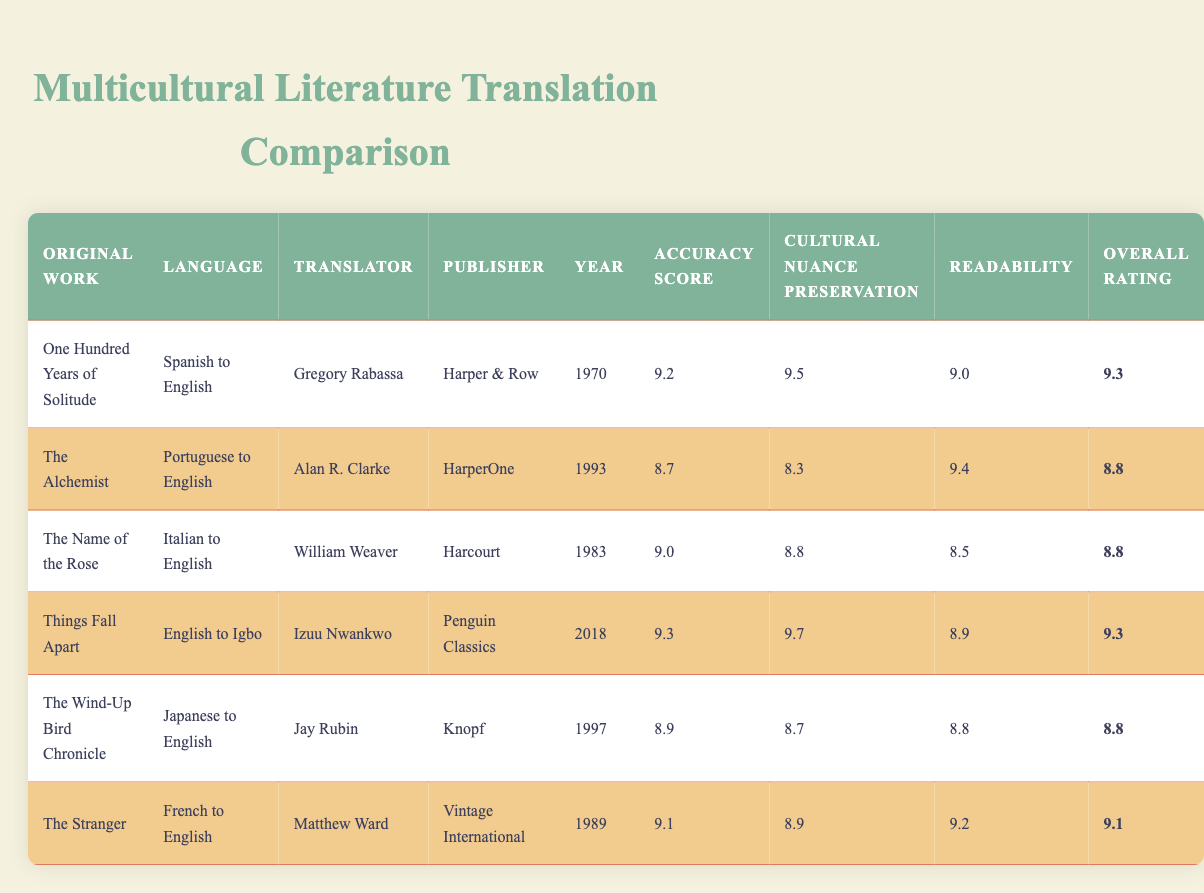What is the overall rating of "One Hundred Years of Solitude"? The overall rating for "One Hundred Years of Solitude" is displayed in the last column of its row in the table, and the value is listed as 9.3.
Answer: 9.3 Which translator has the highest accuracy score and what is that score? To find the highest accuracy score, we can look through all the rows in the "Accuracy Score" column. "Things Fall Apart" has the highest accuracy score of 9.3.
Answer: Izuu Nwankwo, 9.3 Do any translations have a cultural nuance preservation score of 9.5 or higher? Checking the "Cultural Nuance Preservation" column, I see that "One Hundred Years of Solitude" has a score of 9.5 and "Things Fall Apart" has a score of 9.7.
Answer: Yes, two translations What is the average readability score of the translations listed? To find the average readability score, I sum the readability scores: (9.0 + 9.4 + 8.5 + 8.9 + 8.8 + 9.2) = 53.8. The number of translations is 6, so the average is 53.8 / 6 = 8.9667, which rounds to 9.
Answer: 9 Did any translation published before 1990 receive an overall rating of 9 or higher? I check the "Year" column for any years before 1990 and find that both "One Hundred Years of Solitude" (1970) and "The Stranger" (1989) have overall ratings of 9.3 and 9.1, respectively. Therefore, yes, both translations qualify.
Answer: Yes, two translations Which work has the lowest cultural nuance preservation score? I look through the "Cultural Nuance Preservation" column to determine which score is the lowest. "The Alchemist" has the lowest score of 8.3.
Answer: The Alchemist What can be concluded about the relationship between readability and accuracy score for the translations? To examine this relationship, I observe that the translations tend to show higher readability scores alongside high accuracy scores, although not perfectly correlated. For instance, "The Alchemist" has a relatively high readability score (9.4) but a lower accuracy score (8.7), while "Things Fall Apart" has both high scores (9.3 accuracy and 8.9 readability).
Answer: Overall, higher accuracy tends to align with higher readability, but exceptions exist Is there a translation with an overall rating of 8.8 that has a cultural nuance preservation score below 9? Both "The Alchemist" and "The Name of the Rose" have an overall rating of 8.8, but "The Alchemist" has a cultural nuance preservation score of 8.3, which is below 9.
Answer: Yes, The Alchemist 